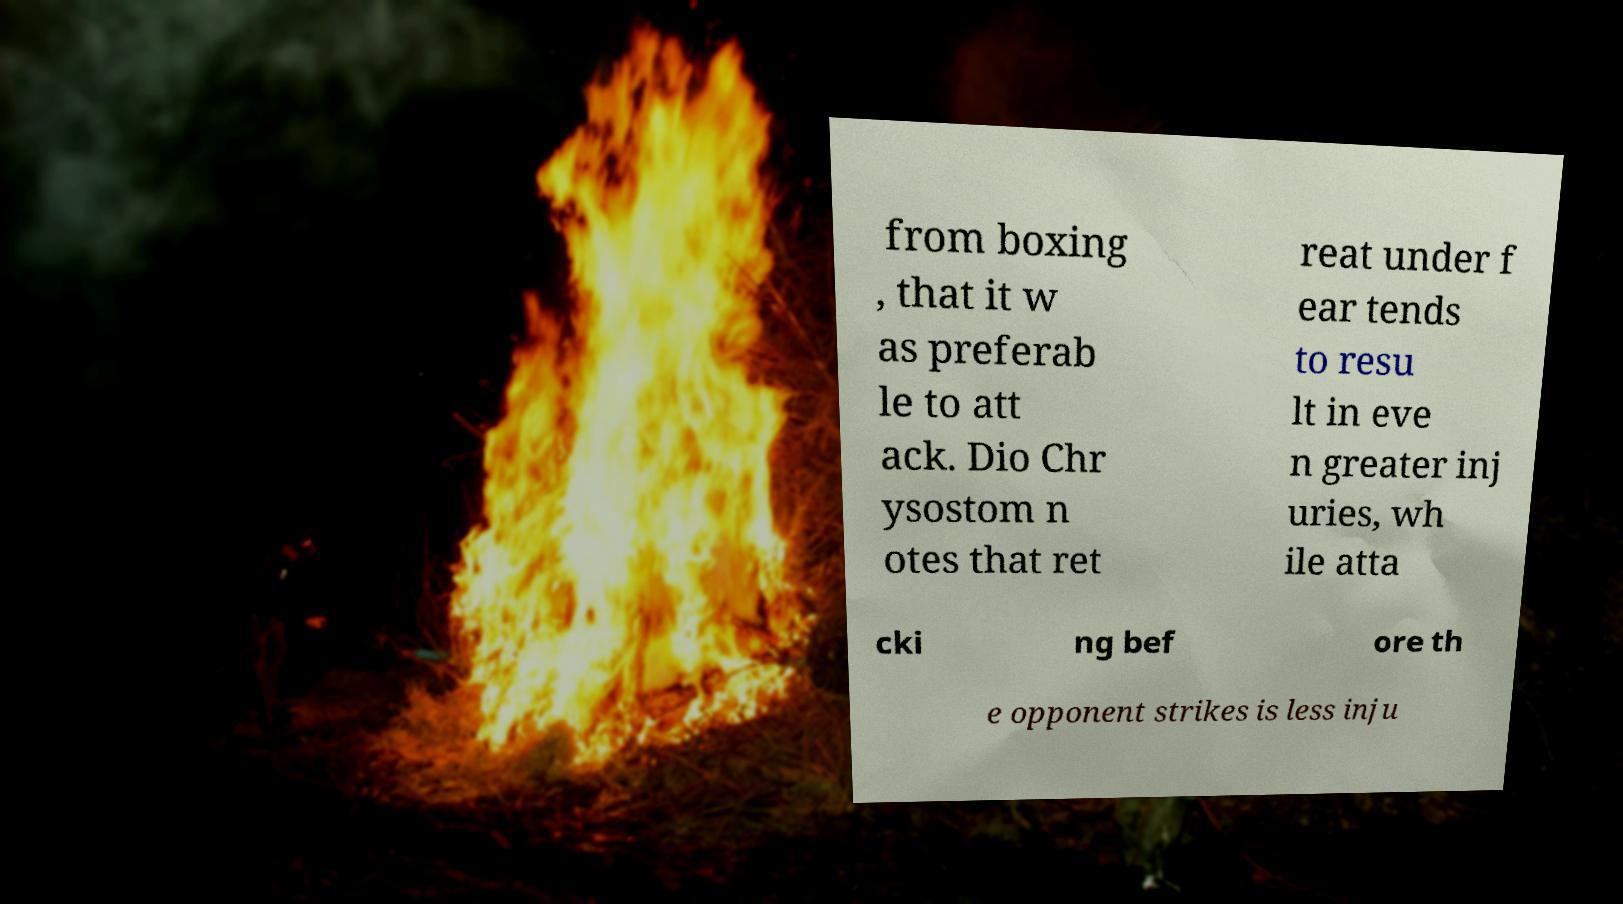Could you assist in decoding the text presented in this image and type it out clearly? from boxing , that it w as preferab le to att ack. Dio Chr ysostom n otes that ret reat under f ear tends to resu lt in eve n greater inj uries, wh ile atta cki ng bef ore th e opponent strikes is less inju 